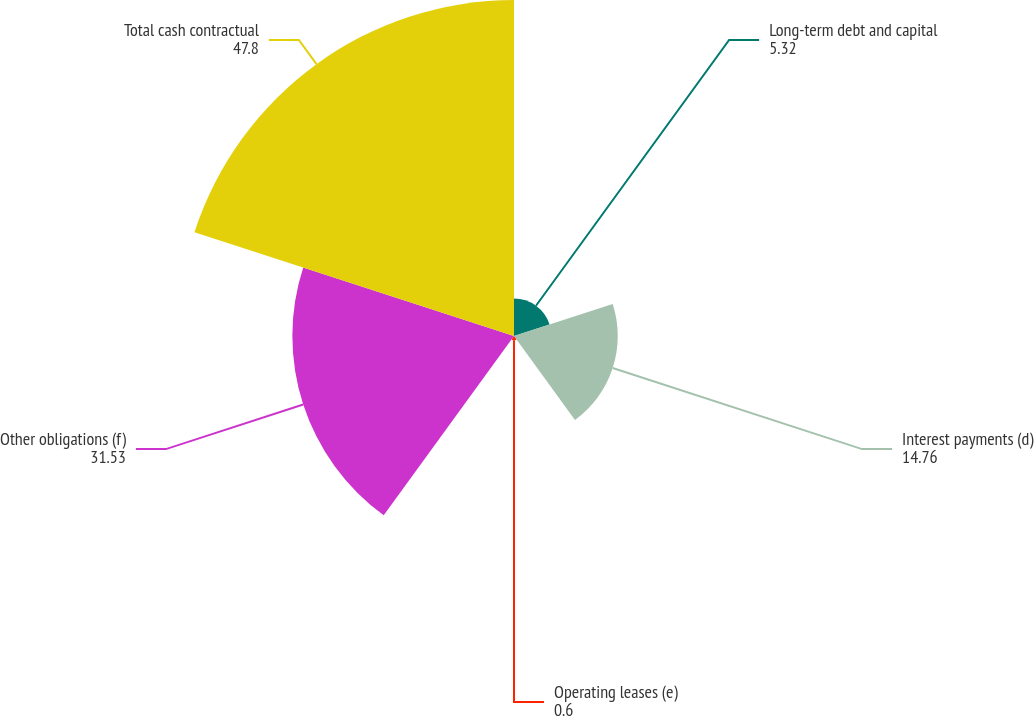<chart> <loc_0><loc_0><loc_500><loc_500><pie_chart><fcel>Long-term debt and capital<fcel>Interest payments (d)<fcel>Operating leases (e)<fcel>Other obligations (f)<fcel>Total cash contractual<nl><fcel>5.32%<fcel>14.76%<fcel>0.6%<fcel>31.53%<fcel>47.8%<nl></chart> 